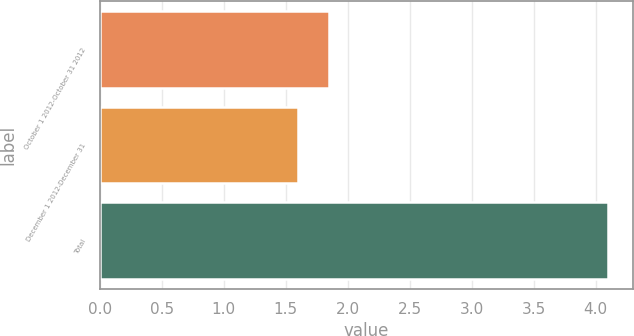Convert chart to OTSL. <chart><loc_0><loc_0><loc_500><loc_500><bar_chart><fcel>October 1 2012-October 31 2012<fcel>December 1 2012-December 31<fcel>Total<nl><fcel>1.85<fcel>1.6<fcel>4.1<nl></chart> 